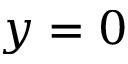Convert formula to latex. <formula><loc_0><loc_0><loc_500><loc_500>y = 0</formula> 